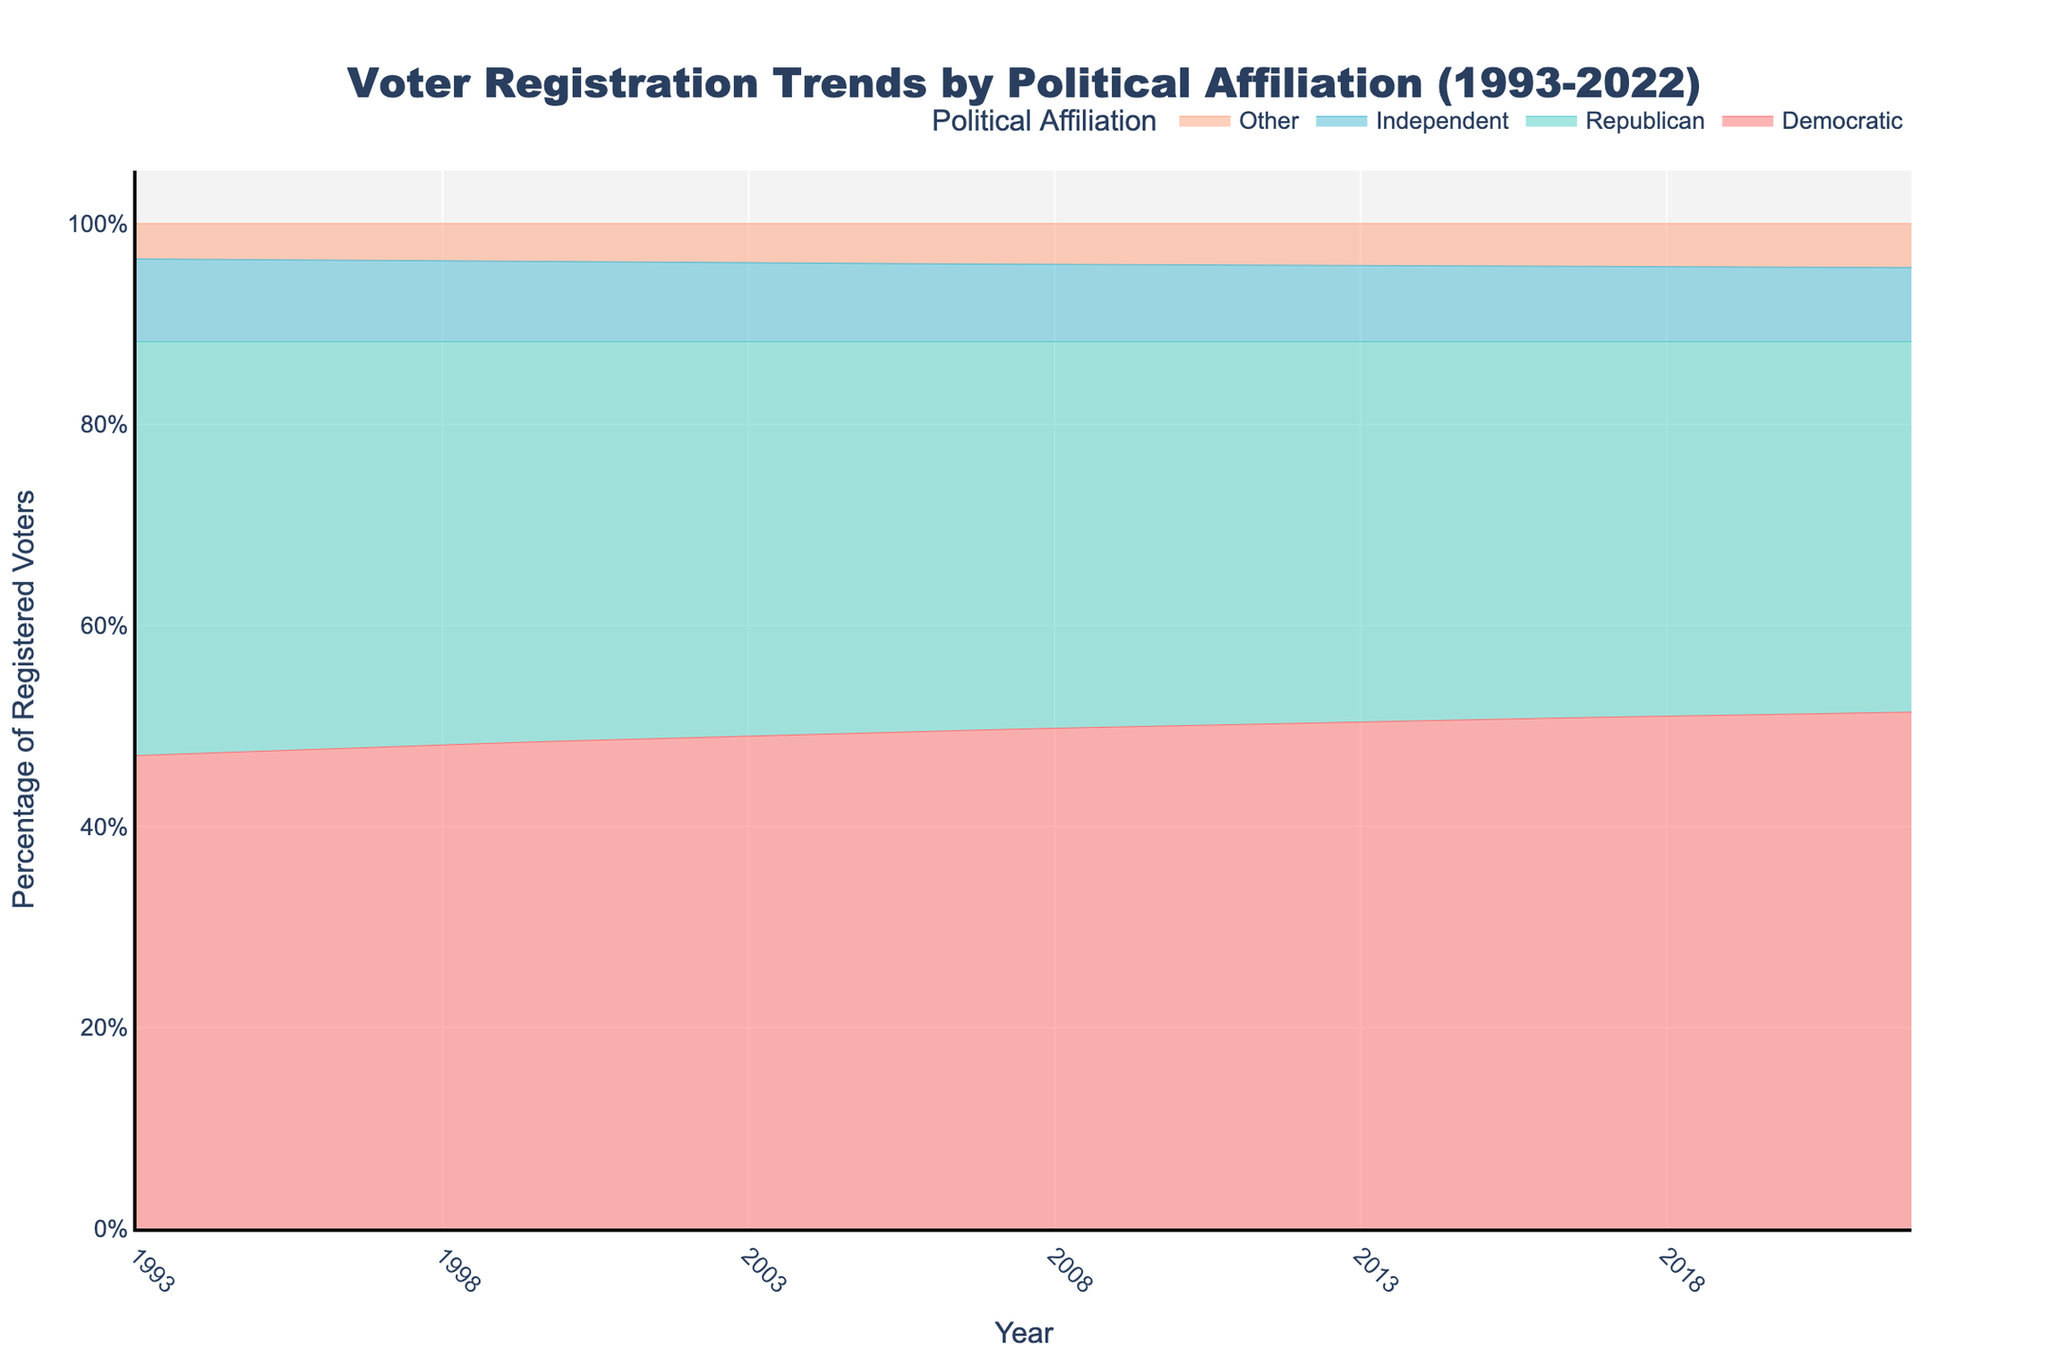What is the title of the figure? The title is usually found at the top of the figure. It provides an overview of what the plot is representing.
Answer: Voter Registration Trends by Political Affiliation (1993-2022) Which political affiliation had the highest percentage of registered voters in 1993? To answer this, look at the step area closest to the top of the figure for the year 1993.
Answer: Democratic Which political affiliation showed the most consistent growth over the years? Examining the trends of each political affiliation over the years, identify which one has a steadily increasing line without major fluctuations.
Answer: Democratic In which year did the total percentage of voters identifying as 'Other' surpass 3%? To find this out, observe the area representing 'Other' and note when its percentage exceeds 3%.
Answer: This did not happen; 'Other' stayed below 3% throughout Comparing the years 2000 and 2020, which political affiliation saw the largest increase in their registered voter percentage? Subtract the percentage value at 2000 from the percentage at 2020 for each political affiliation. The largest difference will indicate the largest growth.
Answer: Democratic What was the approximate percentage of Independent voters in 2005? Locate the area for 'Independent' in the year 2005 and estimate its percentage based on its relative height in the stack.
Answer: Approximately 8% Did the Republican registration percentage ever exceed the Democratic registration percentage from 1993 to 2022? Analyze the graph to check if the area representing 'Republican' ever rises above 'Democratic'.
Answer: No By how much did the Democratic registration percentage increase from 1993 to 2022? Find the height of the Democratic area in 1993 and 2022, then calculate the difference.
Answer: Approximately 22% Which political affiliation had the smallest change in registration percentage over the years? Compare the starting and ending registration percentages for each political affiliation and determine which one has the smallest difference.
Answer: Other 